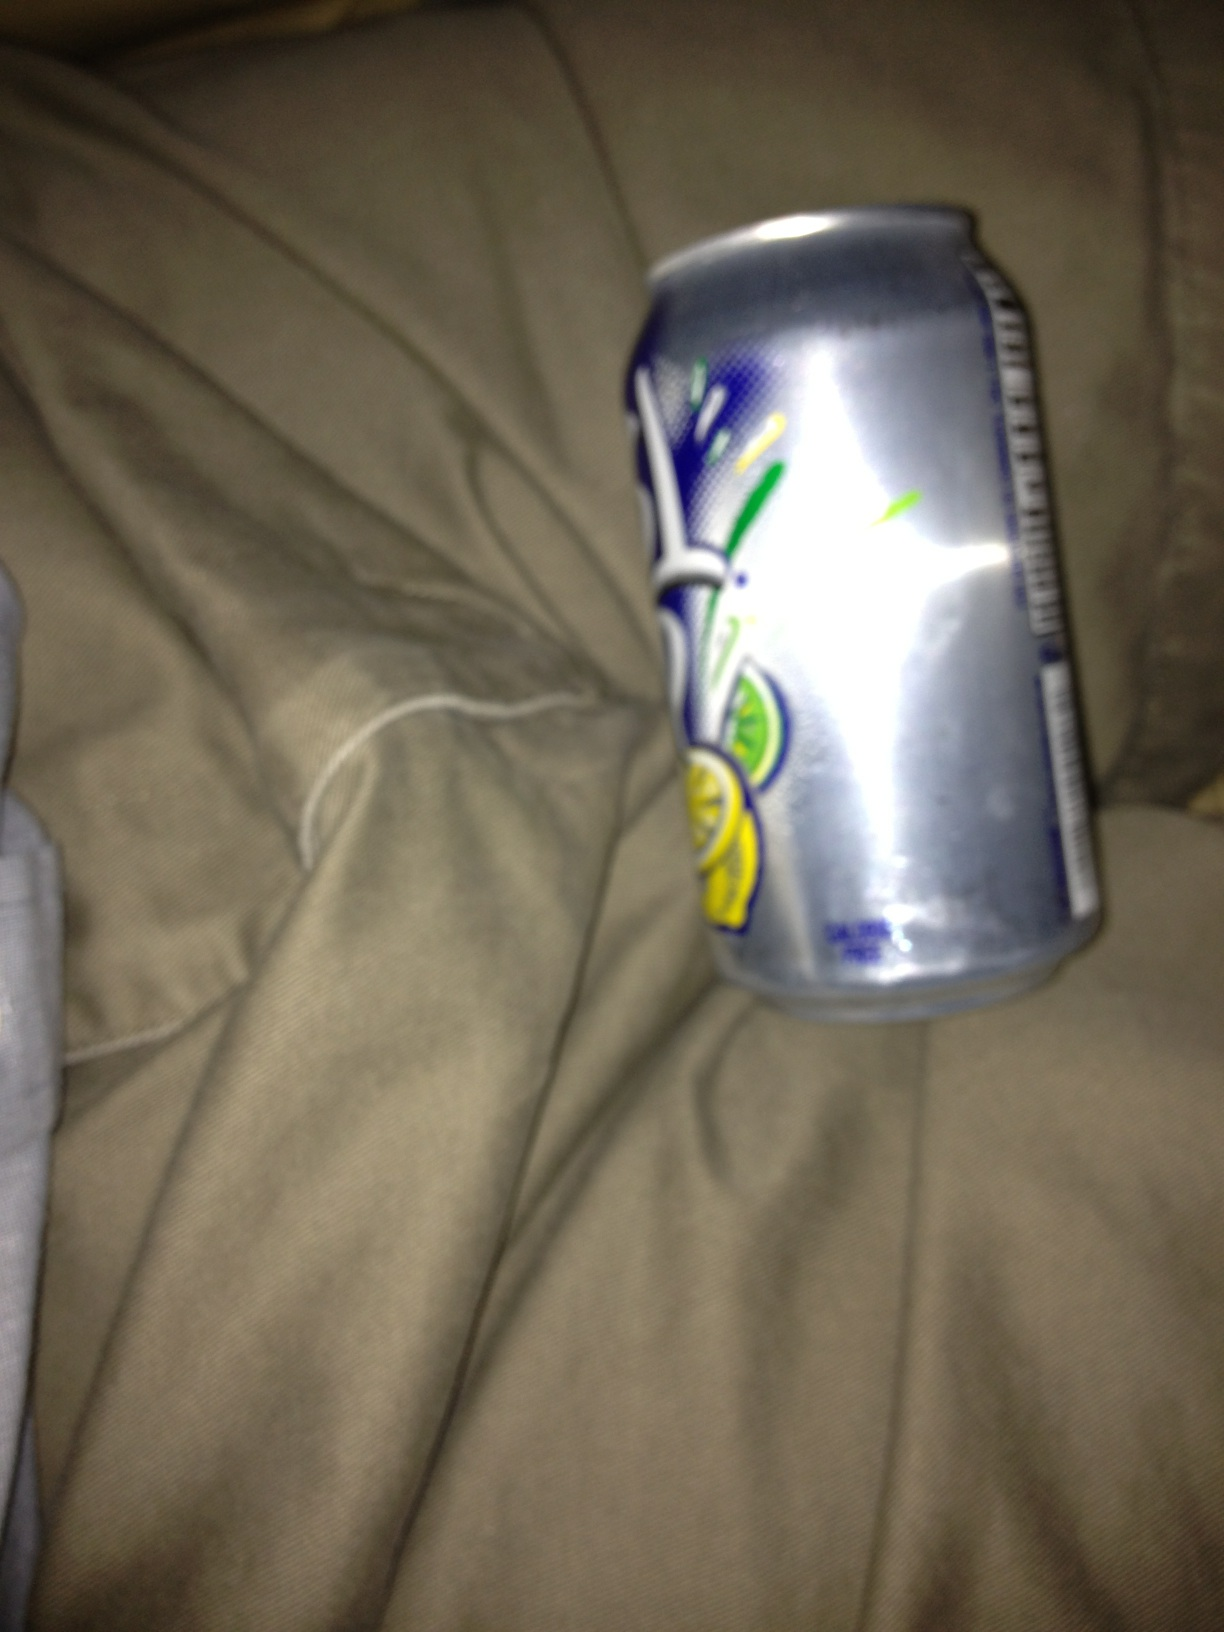What is this? This image shows a crumpled can of Sprite, which is a lemon-lime flavored, caffeine-free soft drink produced by the Coca-Cola Company. 